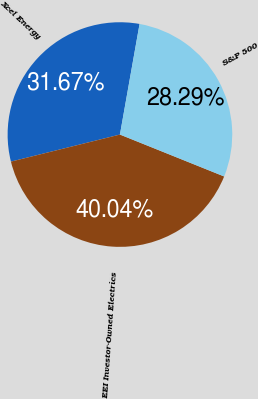Convert chart to OTSL. <chart><loc_0><loc_0><loc_500><loc_500><pie_chart><fcel>Xcel Energy<fcel>EEI Investor-Owned Electrics<fcel>S&P 500<nl><fcel>31.67%<fcel>40.04%<fcel>28.29%<nl></chart> 